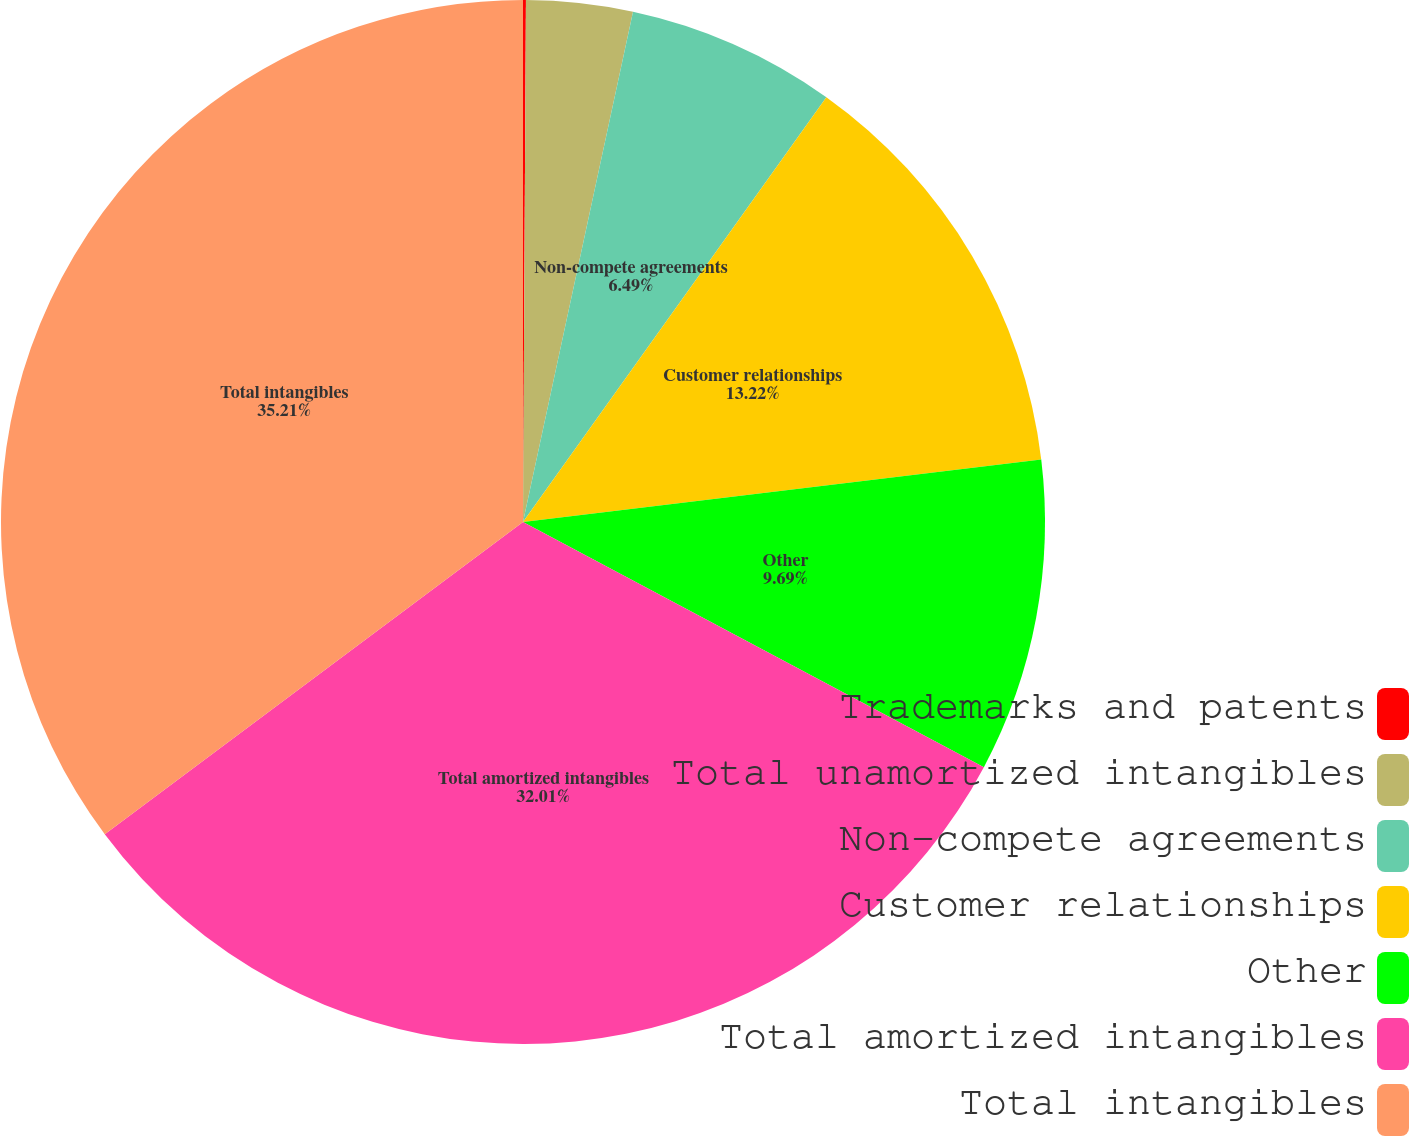Convert chart to OTSL. <chart><loc_0><loc_0><loc_500><loc_500><pie_chart><fcel>Trademarks and patents<fcel>Total unamortized intangibles<fcel>Non-compete agreements<fcel>Customer relationships<fcel>Other<fcel>Total amortized intangibles<fcel>Total intangibles<nl><fcel>0.09%<fcel>3.29%<fcel>6.49%<fcel>13.22%<fcel>9.69%<fcel>32.01%<fcel>35.21%<nl></chart> 